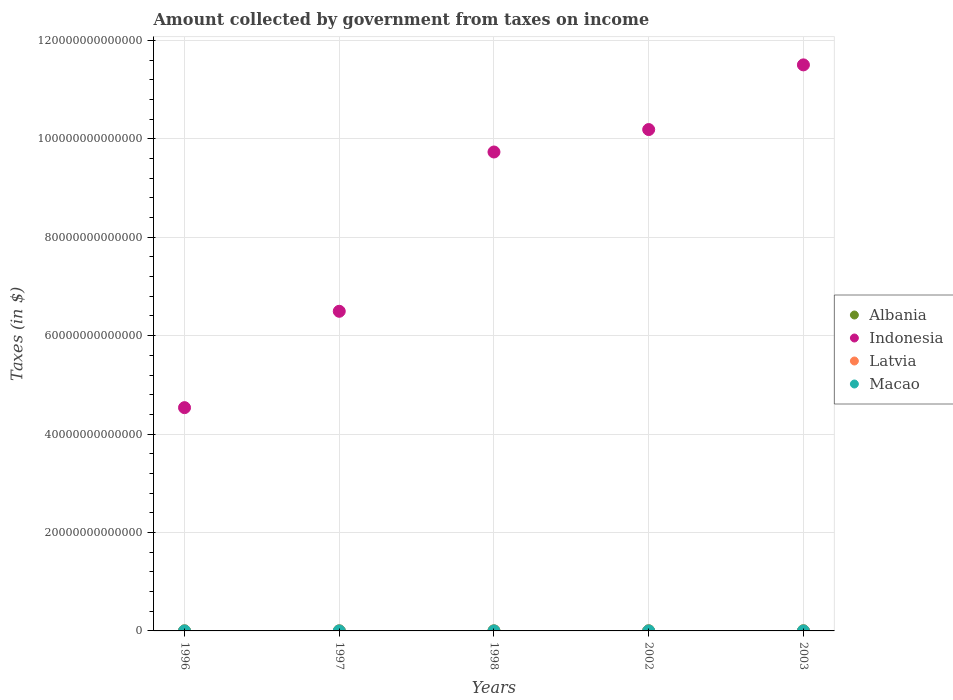How many different coloured dotlines are there?
Offer a terse response. 4. Is the number of dotlines equal to the number of legend labels?
Make the answer very short. Yes. What is the amount collected by government from taxes on income in Albania in 1996?
Your response must be concise. 4.81e+09. Across all years, what is the maximum amount collected by government from taxes on income in Albania?
Make the answer very short. 2.25e+1. Across all years, what is the minimum amount collected by government from taxes on income in Macao?
Provide a succinct answer. 7.81e+08. In which year was the amount collected by government from taxes on income in Latvia maximum?
Offer a terse response. 2002. What is the total amount collected by government from taxes on income in Latvia in the graph?
Provide a short and direct response. 7.40e+08. What is the difference between the amount collected by government from taxes on income in Macao in 1996 and that in 2002?
Give a very brief answer. -2.24e+07. What is the difference between the amount collected by government from taxes on income in Albania in 2002 and the amount collected by government from taxes on income in Indonesia in 1997?
Offer a very short reply. -6.49e+13. What is the average amount collected by government from taxes on income in Macao per year?
Offer a terse response. 8.64e+08. In the year 1998, what is the difference between the amount collected by government from taxes on income in Macao and amount collected by government from taxes on income in Albania?
Keep it short and to the point. -5.47e+09. What is the ratio of the amount collected by government from taxes on income in Albania in 1998 to that in 2003?
Your response must be concise. 0.28. Is the amount collected by government from taxes on income in Latvia in 1998 less than that in 2003?
Keep it short and to the point. Yes. What is the difference between the highest and the second highest amount collected by government from taxes on income in Albania?
Give a very brief answer. 1.61e+09. What is the difference between the highest and the lowest amount collected by government from taxes on income in Macao?
Give a very brief answer. 1.51e+08. In how many years, is the amount collected by government from taxes on income in Indonesia greater than the average amount collected by government from taxes on income in Indonesia taken over all years?
Provide a short and direct response. 3. Is it the case that in every year, the sum of the amount collected by government from taxes on income in Macao and amount collected by government from taxes on income in Albania  is greater than the sum of amount collected by government from taxes on income in Latvia and amount collected by government from taxes on income in Indonesia?
Keep it short and to the point. No. Is the amount collected by government from taxes on income in Macao strictly less than the amount collected by government from taxes on income in Latvia over the years?
Ensure brevity in your answer.  No. How many dotlines are there?
Your answer should be very brief. 4. How many years are there in the graph?
Offer a terse response. 5. What is the difference between two consecutive major ticks on the Y-axis?
Keep it short and to the point. 2.00e+13. Does the graph contain grids?
Your answer should be very brief. Yes. Where does the legend appear in the graph?
Make the answer very short. Center right. What is the title of the graph?
Give a very brief answer. Amount collected by government from taxes on income. What is the label or title of the Y-axis?
Your answer should be compact. Taxes (in $). What is the Taxes (in $) in Albania in 1996?
Offer a terse response. 4.81e+09. What is the Taxes (in $) of Indonesia in 1996?
Your response must be concise. 4.54e+13. What is the Taxes (in $) in Latvia in 1996?
Keep it short and to the point. 5.74e+07. What is the Taxes (in $) in Macao in 1996?
Offer a terse response. 8.51e+08. What is the Taxes (in $) in Albania in 1997?
Provide a short and direct response. 3.59e+09. What is the Taxes (in $) of Indonesia in 1997?
Provide a short and direct response. 6.49e+13. What is the Taxes (in $) in Latvia in 1997?
Keep it short and to the point. 1.31e+08. What is the Taxes (in $) of Macao in 1997?
Make the answer very short. 8.85e+08. What is the Taxes (in $) in Albania in 1998?
Keep it short and to the point. 6.40e+09. What is the Taxes (in $) in Indonesia in 1998?
Provide a succinct answer. 9.73e+13. What is the Taxes (in $) of Latvia in 1998?
Keep it short and to the point. 1.54e+08. What is the Taxes (in $) of Macao in 1998?
Your response must be concise. 9.32e+08. What is the Taxes (in $) of Albania in 2002?
Your answer should be compact. 2.09e+1. What is the Taxes (in $) of Indonesia in 2002?
Offer a terse response. 1.02e+14. What is the Taxes (in $) of Latvia in 2002?
Your answer should be compact. 2.01e+08. What is the Taxes (in $) in Macao in 2002?
Your answer should be very brief. 8.73e+08. What is the Taxes (in $) of Albania in 2003?
Give a very brief answer. 2.25e+1. What is the Taxes (in $) of Indonesia in 2003?
Make the answer very short. 1.15e+14. What is the Taxes (in $) in Latvia in 2003?
Provide a short and direct response. 1.98e+08. What is the Taxes (in $) in Macao in 2003?
Your answer should be very brief. 7.81e+08. Across all years, what is the maximum Taxes (in $) of Albania?
Ensure brevity in your answer.  2.25e+1. Across all years, what is the maximum Taxes (in $) in Indonesia?
Provide a succinct answer. 1.15e+14. Across all years, what is the maximum Taxes (in $) in Latvia?
Offer a very short reply. 2.01e+08. Across all years, what is the maximum Taxes (in $) in Macao?
Provide a succinct answer. 9.32e+08. Across all years, what is the minimum Taxes (in $) of Albania?
Offer a very short reply. 3.59e+09. Across all years, what is the minimum Taxes (in $) in Indonesia?
Your answer should be very brief. 4.54e+13. Across all years, what is the minimum Taxes (in $) of Latvia?
Your answer should be compact. 5.74e+07. Across all years, what is the minimum Taxes (in $) of Macao?
Keep it short and to the point. 7.81e+08. What is the total Taxes (in $) in Albania in the graph?
Give a very brief answer. 5.82e+1. What is the total Taxes (in $) of Indonesia in the graph?
Ensure brevity in your answer.  4.25e+14. What is the total Taxes (in $) in Latvia in the graph?
Ensure brevity in your answer.  7.40e+08. What is the total Taxes (in $) of Macao in the graph?
Provide a succinct answer. 4.32e+09. What is the difference between the Taxes (in $) of Albania in 1996 and that in 1997?
Make the answer very short. 1.22e+09. What is the difference between the Taxes (in $) in Indonesia in 1996 and that in 1997?
Your response must be concise. -1.96e+13. What is the difference between the Taxes (in $) of Latvia in 1996 and that in 1997?
Give a very brief answer. -7.31e+07. What is the difference between the Taxes (in $) of Macao in 1996 and that in 1997?
Your answer should be compact. -3.37e+07. What is the difference between the Taxes (in $) of Albania in 1996 and that in 1998?
Provide a succinct answer. -1.59e+09. What is the difference between the Taxes (in $) of Indonesia in 1996 and that in 1998?
Provide a short and direct response. -5.19e+13. What is the difference between the Taxes (in $) of Latvia in 1996 and that in 1998?
Your answer should be compact. -9.68e+07. What is the difference between the Taxes (in $) of Macao in 1996 and that in 1998?
Keep it short and to the point. -8.11e+07. What is the difference between the Taxes (in $) of Albania in 1996 and that in 2002?
Provide a short and direct response. -1.61e+1. What is the difference between the Taxes (in $) of Indonesia in 1996 and that in 2002?
Provide a short and direct response. -5.65e+13. What is the difference between the Taxes (in $) of Latvia in 1996 and that in 2002?
Provide a short and direct response. -1.43e+08. What is the difference between the Taxes (in $) in Macao in 1996 and that in 2002?
Offer a very short reply. -2.24e+07. What is the difference between the Taxes (in $) in Albania in 1996 and that in 2003?
Ensure brevity in your answer.  -1.77e+1. What is the difference between the Taxes (in $) of Indonesia in 1996 and that in 2003?
Your response must be concise. -6.96e+13. What is the difference between the Taxes (in $) in Latvia in 1996 and that in 2003?
Offer a very short reply. -1.40e+08. What is the difference between the Taxes (in $) of Macao in 1996 and that in 2003?
Your answer should be compact. 7.02e+07. What is the difference between the Taxes (in $) in Albania in 1997 and that in 1998?
Provide a succinct answer. -2.81e+09. What is the difference between the Taxes (in $) in Indonesia in 1997 and that in 1998?
Make the answer very short. -3.24e+13. What is the difference between the Taxes (in $) of Latvia in 1997 and that in 1998?
Ensure brevity in your answer.  -2.37e+07. What is the difference between the Taxes (in $) of Macao in 1997 and that in 1998?
Provide a short and direct response. -4.74e+07. What is the difference between the Taxes (in $) of Albania in 1997 and that in 2002?
Your answer should be compact. -1.73e+1. What is the difference between the Taxes (in $) of Indonesia in 1997 and that in 2002?
Your response must be concise. -3.69e+13. What is the difference between the Taxes (in $) of Latvia in 1997 and that in 2002?
Provide a short and direct response. -7.02e+07. What is the difference between the Taxes (in $) in Macao in 1997 and that in 2002?
Ensure brevity in your answer.  1.14e+07. What is the difference between the Taxes (in $) of Albania in 1997 and that in 2003?
Provide a succinct answer. -1.89e+1. What is the difference between the Taxes (in $) in Indonesia in 1997 and that in 2003?
Your response must be concise. -5.01e+13. What is the difference between the Taxes (in $) of Latvia in 1997 and that in 2003?
Your response must be concise. -6.71e+07. What is the difference between the Taxes (in $) in Macao in 1997 and that in 2003?
Your answer should be compact. 1.04e+08. What is the difference between the Taxes (in $) of Albania in 1998 and that in 2002?
Offer a terse response. -1.45e+1. What is the difference between the Taxes (in $) of Indonesia in 1998 and that in 2002?
Offer a very short reply. -4.56e+12. What is the difference between the Taxes (in $) of Latvia in 1998 and that in 2002?
Your answer should be compact. -4.66e+07. What is the difference between the Taxes (in $) in Macao in 1998 and that in 2002?
Ensure brevity in your answer.  5.88e+07. What is the difference between the Taxes (in $) of Albania in 1998 and that in 2003?
Make the answer very short. -1.61e+1. What is the difference between the Taxes (in $) of Indonesia in 1998 and that in 2003?
Provide a succinct answer. -1.77e+13. What is the difference between the Taxes (in $) of Latvia in 1998 and that in 2003?
Provide a succinct answer. -4.34e+07. What is the difference between the Taxes (in $) in Macao in 1998 and that in 2003?
Provide a succinct answer. 1.51e+08. What is the difference between the Taxes (in $) in Albania in 2002 and that in 2003?
Your answer should be very brief. -1.61e+09. What is the difference between the Taxes (in $) of Indonesia in 2002 and that in 2003?
Provide a succinct answer. -1.31e+13. What is the difference between the Taxes (in $) in Latvia in 2002 and that in 2003?
Offer a very short reply. 3.18e+06. What is the difference between the Taxes (in $) in Macao in 2002 and that in 2003?
Your response must be concise. 9.25e+07. What is the difference between the Taxes (in $) in Albania in 1996 and the Taxes (in $) in Indonesia in 1997?
Ensure brevity in your answer.  -6.49e+13. What is the difference between the Taxes (in $) in Albania in 1996 and the Taxes (in $) in Latvia in 1997?
Your answer should be compact. 4.68e+09. What is the difference between the Taxes (in $) in Albania in 1996 and the Taxes (in $) in Macao in 1997?
Give a very brief answer. 3.92e+09. What is the difference between the Taxes (in $) of Indonesia in 1996 and the Taxes (in $) of Latvia in 1997?
Offer a very short reply. 4.54e+13. What is the difference between the Taxes (in $) of Indonesia in 1996 and the Taxes (in $) of Macao in 1997?
Make the answer very short. 4.54e+13. What is the difference between the Taxes (in $) of Latvia in 1996 and the Taxes (in $) of Macao in 1997?
Provide a short and direct response. -8.27e+08. What is the difference between the Taxes (in $) of Albania in 1996 and the Taxes (in $) of Indonesia in 1998?
Your answer should be very brief. -9.73e+13. What is the difference between the Taxes (in $) of Albania in 1996 and the Taxes (in $) of Latvia in 1998?
Your answer should be compact. 4.65e+09. What is the difference between the Taxes (in $) in Albania in 1996 and the Taxes (in $) in Macao in 1998?
Your response must be concise. 3.88e+09. What is the difference between the Taxes (in $) in Indonesia in 1996 and the Taxes (in $) in Latvia in 1998?
Keep it short and to the point. 4.54e+13. What is the difference between the Taxes (in $) in Indonesia in 1996 and the Taxes (in $) in Macao in 1998?
Keep it short and to the point. 4.54e+13. What is the difference between the Taxes (in $) in Latvia in 1996 and the Taxes (in $) in Macao in 1998?
Give a very brief answer. -8.75e+08. What is the difference between the Taxes (in $) of Albania in 1996 and the Taxes (in $) of Indonesia in 2002?
Ensure brevity in your answer.  -1.02e+14. What is the difference between the Taxes (in $) in Albania in 1996 and the Taxes (in $) in Latvia in 2002?
Provide a succinct answer. 4.61e+09. What is the difference between the Taxes (in $) in Albania in 1996 and the Taxes (in $) in Macao in 2002?
Keep it short and to the point. 3.93e+09. What is the difference between the Taxes (in $) in Indonesia in 1996 and the Taxes (in $) in Latvia in 2002?
Ensure brevity in your answer.  4.54e+13. What is the difference between the Taxes (in $) of Indonesia in 1996 and the Taxes (in $) of Macao in 2002?
Ensure brevity in your answer.  4.54e+13. What is the difference between the Taxes (in $) of Latvia in 1996 and the Taxes (in $) of Macao in 2002?
Ensure brevity in your answer.  -8.16e+08. What is the difference between the Taxes (in $) in Albania in 1996 and the Taxes (in $) in Indonesia in 2003?
Ensure brevity in your answer.  -1.15e+14. What is the difference between the Taxes (in $) in Albania in 1996 and the Taxes (in $) in Latvia in 2003?
Your answer should be compact. 4.61e+09. What is the difference between the Taxes (in $) of Albania in 1996 and the Taxes (in $) of Macao in 2003?
Your answer should be compact. 4.03e+09. What is the difference between the Taxes (in $) of Indonesia in 1996 and the Taxes (in $) of Latvia in 2003?
Keep it short and to the point. 4.54e+13. What is the difference between the Taxes (in $) in Indonesia in 1996 and the Taxes (in $) in Macao in 2003?
Give a very brief answer. 4.54e+13. What is the difference between the Taxes (in $) in Latvia in 1996 and the Taxes (in $) in Macao in 2003?
Provide a short and direct response. -7.23e+08. What is the difference between the Taxes (in $) in Albania in 1997 and the Taxes (in $) in Indonesia in 1998?
Make the answer very short. -9.73e+13. What is the difference between the Taxes (in $) of Albania in 1997 and the Taxes (in $) of Latvia in 1998?
Offer a very short reply. 3.44e+09. What is the difference between the Taxes (in $) of Albania in 1997 and the Taxes (in $) of Macao in 1998?
Offer a terse response. 2.66e+09. What is the difference between the Taxes (in $) of Indonesia in 1997 and the Taxes (in $) of Latvia in 1998?
Offer a very short reply. 6.49e+13. What is the difference between the Taxes (in $) in Indonesia in 1997 and the Taxes (in $) in Macao in 1998?
Make the answer very short. 6.49e+13. What is the difference between the Taxes (in $) of Latvia in 1997 and the Taxes (in $) of Macao in 1998?
Give a very brief answer. -8.02e+08. What is the difference between the Taxes (in $) in Albania in 1997 and the Taxes (in $) in Indonesia in 2002?
Your response must be concise. -1.02e+14. What is the difference between the Taxes (in $) in Albania in 1997 and the Taxes (in $) in Latvia in 2002?
Provide a short and direct response. 3.39e+09. What is the difference between the Taxes (in $) of Albania in 1997 and the Taxes (in $) of Macao in 2002?
Your answer should be compact. 2.72e+09. What is the difference between the Taxes (in $) in Indonesia in 1997 and the Taxes (in $) in Latvia in 2002?
Give a very brief answer. 6.49e+13. What is the difference between the Taxes (in $) in Indonesia in 1997 and the Taxes (in $) in Macao in 2002?
Your response must be concise. 6.49e+13. What is the difference between the Taxes (in $) of Latvia in 1997 and the Taxes (in $) of Macao in 2002?
Provide a short and direct response. -7.43e+08. What is the difference between the Taxes (in $) of Albania in 1997 and the Taxes (in $) of Indonesia in 2003?
Your answer should be very brief. -1.15e+14. What is the difference between the Taxes (in $) in Albania in 1997 and the Taxes (in $) in Latvia in 2003?
Your answer should be very brief. 3.39e+09. What is the difference between the Taxes (in $) of Albania in 1997 and the Taxes (in $) of Macao in 2003?
Offer a very short reply. 2.81e+09. What is the difference between the Taxes (in $) in Indonesia in 1997 and the Taxes (in $) in Latvia in 2003?
Offer a terse response. 6.49e+13. What is the difference between the Taxes (in $) of Indonesia in 1997 and the Taxes (in $) of Macao in 2003?
Keep it short and to the point. 6.49e+13. What is the difference between the Taxes (in $) of Latvia in 1997 and the Taxes (in $) of Macao in 2003?
Give a very brief answer. -6.50e+08. What is the difference between the Taxes (in $) in Albania in 1998 and the Taxes (in $) in Indonesia in 2002?
Keep it short and to the point. -1.02e+14. What is the difference between the Taxes (in $) of Albania in 1998 and the Taxes (in $) of Latvia in 2002?
Offer a terse response. 6.20e+09. What is the difference between the Taxes (in $) in Albania in 1998 and the Taxes (in $) in Macao in 2002?
Provide a succinct answer. 5.53e+09. What is the difference between the Taxes (in $) in Indonesia in 1998 and the Taxes (in $) in Latvia in 2002?
Keep it short and to the point. 9.73e+13. What is the difference between the Taxes (in $) of Indonesia in 1998 and the Taxes (in $) of Macao in 2002?
Your answer should be very brief. 9.73e+13. What is the difference between the Taxes (in $) in Latvia in 1998 and the Taxes (in $) in Macao in 2002?
Ensure brevity in your answer.  -7.19e+08. What is the difference between the Taxes (in $) in Albania in 1998 and the Taxes (in $) in Indonesia in 2003?
Your answer should be very brief. -1.15e+14. What is the difference between the Taxes (in $) in Albania in 1998 and the Taxes (in $) in Latvia in 2003?
Offer a very short reply. 6.20e+09. What is the difference between the Taxes (in $) of Albania in 1998 and the Taxes (in $) of Macao in 2003?
Provide a succinct answer. 5.62e+09. What is the difference between the Taxes (in $) of Indonesia in 1998 and the Taxes (in $) of Latvia in 2003?
Your response must be concise. 9.73e+13. What is the difference between the Taxes (in $) of Indonesia in 1998 and the Taxes (in $) of Macao in 2003?
Your answer should be very brief. 9.73e+13. What is the difference between the Taxes (in $) of Latvia in 1998 and the Taxes (in $) of Macao in 2003?
Provide a succinct answer. -6.27e+08. What is the difference between the Taxes (in $) in Albania in 2002 and the Taxes (in $) in Indonesia in 2003?
Your answer should be compact. -1.15e+14. What is the difference between the Taxes (in $) of Albania in 2002 and the Taxes (in $) of Latvia in 2003?
Your answer should be compact. 2.07e+1. What is the difference between the Taxes (in $) in Albania in 2002 and the Taxes (in $) in Macao in 2003?
Provide a short and direct response. 2.01e+1. What is the difference between the Taxes (in $) in Indonesia in 2002 and the Taxes (in $) in Latvia in 2003?
Make the answer very short. 1.02e+14. What is the difference between the Taxes (in $) in Indonesia in 2002 and the Taxes (in $) in Macao in 2003?
Provide a succinct answer. 1.02e+14. What is the difference between the Taxes (in $) of Latvia in 2002 and the Taxes (in $) of Macao in 2003?
Keep it short and to the point. -5.80e+08. What is the average Taxes (in $) of Albania per year?
Your answer should be very brief. 1.16e+1. What is the average Taxes (in $) of Indonesia per year?
Give a very brief answer. 8.49e+13. What is the average Taxes (in $) in Latvia per year?
Offer a very short reply. 1.48e+08. What is the average Taxes (in $) of Macao per year?
Keep it short and to the point. 8.64e+08. In the year 1996, what is the difference between the Taxes (in $) in Albania and Taxes (in $) in Indonesia?
Make the answer very short. -4.54e+13. In the year 1996, what is the difference between the Taxes (in $) in Albania and Taxes (in $) in Latvia?
Your answer should be compact. 4.75e+09. In the year 1996, what is the difference between the Taxes (in $) of Albania and Taxes (in $) of Macao?
Your response must be concise. 3.96e+09. In the year 1996, what is the difference between the Taxes (in $) in Indonesia and Taxes (in $) in Latvia?
Provide a succinct answer. 4.54e+13. In the year 1996, what is the difference between the Taxes (in $) of Indonesia and Taxes (in $) of Macao?
Ensure brevity in your answer.  4.54e+13. In the year 1996, what is the difference between the Taxes (in $) in Latvia and Taxes (in $) in Macao?
Give a very brief answer. -7.94e+08. In the year 1997, what is the difference between the Taxes (in $) in Albania and Taxes (in $) in Indonesia?
Make the answer very short. -6.49e+13. In the year 1997, what is the difference between the Taxes (in $) of Albania and Taxes (in $) of Latvia?
Your response must be concise. 3.46e+09. In the year 1997, what is the difference between the Taxes (in $) in Albania and Taxes (in $) in Macao?
Ensure brevity in your answer.  2.71e+09. In the year 1997, what is the difference between the Taxes (in $) of Indonesia and Taxes (in $) of Latvia?
Your response must be concise. 6.49e+13. In the year 1997, what is the difference between the Taxes (in $) in Indonesia and Taxes (in $) in Macao?
Your answer should be compact. 6.49e+13. In the year 1997, what is the difference between the Taxes (in $) in Latvia and Taxes (in $) in Macao?
Provide a succinct answer. -7.54e+08. In the year 1998, what is the difference between the Taxes (in $) of Albania and Taxes (in $) of Indonesia?
Provide a short and direct response. -9.73e+13. In the year 1998, what is the difference between the Taxes (in $) in Albania and Taxes (in $) in Latvia?
Make the answer very short. 6.25e+09. In the year 1998, what is the difference between the Taxes (in $) of Albania and Taxes (in $) of Macao?
Ensure brevity in your answer.  5.47e+09. In the year 1998, what is the difference between the Taxes (in $) in Indonesia and Taxes (in $) in Latvia?
Keep it short and to the point. 9.73e+13. In the year 1998, what is the difference between the Taxes (in $) in Indonesia and Taxes (in $) in Macao?
Provide a short and direct response. 9.73e+13. In the year 1998, what is the difference between the Taxes (in $) in Latvia and Taxes (in $) in Macao?
Your response must be concise. -7.78e+08. In the year 2002, what is the difference between the Taxes (in $) in Albania and Taxes (in $) in Indonesia?
Give a very brief answer. -1.02e+14. In the year 2002, what is the difference between the Taxes (in $) in Albania and Taxes (in $) in Latvia?
Your response must be concise. 2.07e+1. In the year 2002, what is the difference between the Taxes (in $) of Albania and Taxes (in $) of Macao?
Give a very brief answer. 2.00e+1. In the year 2002, what is the difference between the Taxes (in $) in Indonesia and Taxes (in $) in Latvia?
Your answer should be very brief. 1.02e+14. In the year 2002, what is the difference between the Taxes (in $) of Indonesia and Taxes (in $) of Macao?
Your answer should be compact. 1.02e+14. In the year 2002, what is the difference between the Taxes (in $) of Latvia and Taxes (in $) of Macao?
Ensure brevity in your answer.  -6.73e+08. In the year 2003, what is the difference between the Taxes (in $) of Albania and Taxes (in $) of Indonesia?
Provide a succinct answer. -1.15e+14. In the year 2003, what is the difference between the Taxes (in $) of Albania and Taxes (in $) of Latvia?
Provide a short and direct response. 2.23e+1. In the year 2003, what is the difference between the Taxes (in $) in Albania and Taxes (in $) in Macao?
Ensure brevity in your answer.  2.17e+1. In the year 2003, what is the difference between the Taxes (in $) of Indonesia and Taxes (in $) of Latvia?
Provide a succinct answer. 1.15e+14. In the year 2003, what is the difference between the Taxes (in $) in Indonesia and Taxes (in $) in Macao?
Your response must be concise. 1.15e+14. In the year 2003, what is the difference between the Taxes (in $) of Latvia and Taxes (in $) of Macao?
Offer a terse response. -5.83e+08. What is the ratio of the Taxes (in $) of Albania in 1996 to that in 1997?
Keep it short and to the point. 1.34. What is the ratio of the Taxes (in $) of Indonesia in 1996 to that in 1997?
Your response must be concise. 0.7. What is the ratio of the Taxes (in $) in Latvia in 1996 to that in 1997?
Offer a very short reply. 0.44. What is the ratio of the Taxes (in $) of Macao in 1996 to that in 1997?
Give a very brief answer. 0.96. What is the ratio of the Taxes (in $) of Albania in 1996 to that in 1998?
Your answer should be very brief. 0.75. What is the ratio of the Taxes (in $) of Indonesia in 1996 to that in 1998?
Make the answer very short. 0.47. What is the ratio of the Taxes (in $) of Latvia in 1996 to that in 1998?
Offer a very short reply. 0.37. What is the ratio of the Taxes (in $) in Albania in 1996 to that in 2002?
Provide a succinct answer. 0.23. What is the ratio of the Taxes (in $) of Indonesia in 1996 to that in 2002?
Your answer should be very brief. 0.45. What is the ratio of the Taxes (in $) of Latvia in 1996 to that in 2002?
Provide a succinct answer. 0.29. What is the ratio of the Taxes (in $) of Macao in 1996 to that in 2002?
Provide a short and direct response. 0.97. What is the ratio of the Taxes (in $) of Albania in 1996 to that in 2003?
Give a very brief answer. 0.21. What is the ratio of the Taxes (in $) of Indonesia in 1996 to that in 2003?
Offer a terse response. 0.39. What is the ratio of the Taxes (in $) of Latvia in 1996 to that in 2003?
Keep it short and to the point. 0.29. What is the ratio of the Taxes (in $) of Macao in 1996 to that in 2003?
Your answer should be very brief. 1.09. What is the ratio of the Taxes (in $) in Albania in 1997 to that in 1998?
Ensure brevity in your answer.  0.56. What is the ratio of the Taxes (in $) in Indonesia in 1997 to that in 1998?
Your answer should be very brief. 0.67. What is the ratio of the Taxes (in $) of Latvia in 1997 to that in 1998?
Ensure brevity in your answer.  0.85. What is the ratio of the Taxes (in $) in Macao in 1997 to that in 1998?
Ensure brevity in your answer.  0.95. What is the ratio of the Taxes (in $) of Albania in 1997 to that in 2002?
Provide a short and direct response. 0.17. What is the ratio of the Taxes (in $) in Indonesia in 1997 to that in 2002?
Your answer should be very brief. 0.64. What is the ratio of the Taxes (in $) in Latvia in 1997 to that in 2002?
Provide a succinct answer. 0.65. What is the ratio of the Taxes (in $) in Macao in 1997 to that in 2002?
Offer a very short reply. 1.01. What is the ratio of the Taxes (in $) of Albania in 1997 to that in 2003?
Give a very brief answer. 0.16. What is the ratio of the Taxes (in $) of Indonesia in 1997 to that in 2003?
Offer a very short reply. 0.56. What is the ratio of the Taxes (in $) of Latvia in 1997 to that in 2003?
Offer a terse response. 0.66. What is the ratio of the Taxes (in $) in Macao in 1997 to that in 2003?
Give a very brief answer. 1.13. What is the ratio of the Taxes (in $) of Albania in 1998 to that in 2002?
Your response must be concise. 0.31. What is the ratio of the Taxes (in $) in Indonesia in 1998 to that in 2002?
Your answer should be compact. 0.96. What is the ratio of the Taxes (in $) of Latvia in 1998 to that in 2002?
Give a very brief answer. 0.77. What is the ratio of the Taxes (in $) of Macao in 1998 to that in 2002?
Make the answer very short. 1.07. What is the ratio of the Taxes (in $) in Albania in 1998 to that in 2003?
Offer a terse response. 0.28. What is the ratio of the Taxes (in $) in Indonesia in 1998 to that in 2003?
Give a very brief answer. 0.85. What is the ratio of the Taxes (in $) in Latvia in 1998 to that in 2003?
Ensure brevity in your answer.  0.78. What is the ratio of the Taxes (in $) of Macao in 1998 to that in 2003?
Offer a very short reply. 1.19. What is the ratio of the Taxes (in $) in Albania in 2002 to that in 2003?
Provide a succinct answer. 0.93. What is the ratio of the Taxes (in $) of Indonesia in 2002 to that in 2003?
Make the answer very short. 0.89. What is the ratio of the Taxes (in $) in Latvia in 2002 to that in 2003?
Keep it short and to the point. 1.02. What is the ratio of the Taxes (in $) in Macao in 2002 to that in 2003?
Your answer should be very brief. 1.12. What is the difference between the highest and the second highest Taxes (in $) of Albania?
Make the answer very short. 1.61e+09. What is the difference between the highest and the second highest Taxes (in $) of Indonesia?
Your answer should be compact. 1.31e+13. What is the difference between the highest and the second highest Taxes (in $) of Latvia?
Offer a terse response. 3.18e+06. What is the difference between the highest and the second highest Taxes (in $) of Macao?
Make the answer very short. 4.74e+07. What is the difference between the highest and the lowest Taxes (in $) in Albania?
Offer a very short reply. 1.89e+1. What is the difference between the highest and the lowest Taxes (in $) of Indonesia?
Ensure brevity in your answer.  6.96e+13. What is the difference between the highest and the lowest Taxes (in $) in Latvia?
Your answer should be very brief. 1.43e+08. What is the difference between the highest and the lowest Taxes (in $) of Macao?
Your answer should be very brief. 1.51e+08. 